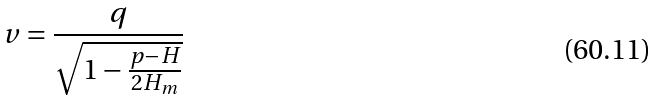<formula> <loc_0><loc_0><loc_500><loc_500>v = \frac { q } { \sqrt { 1 - \frac { p - H } { 2 H _ { m } } } }</formula> 